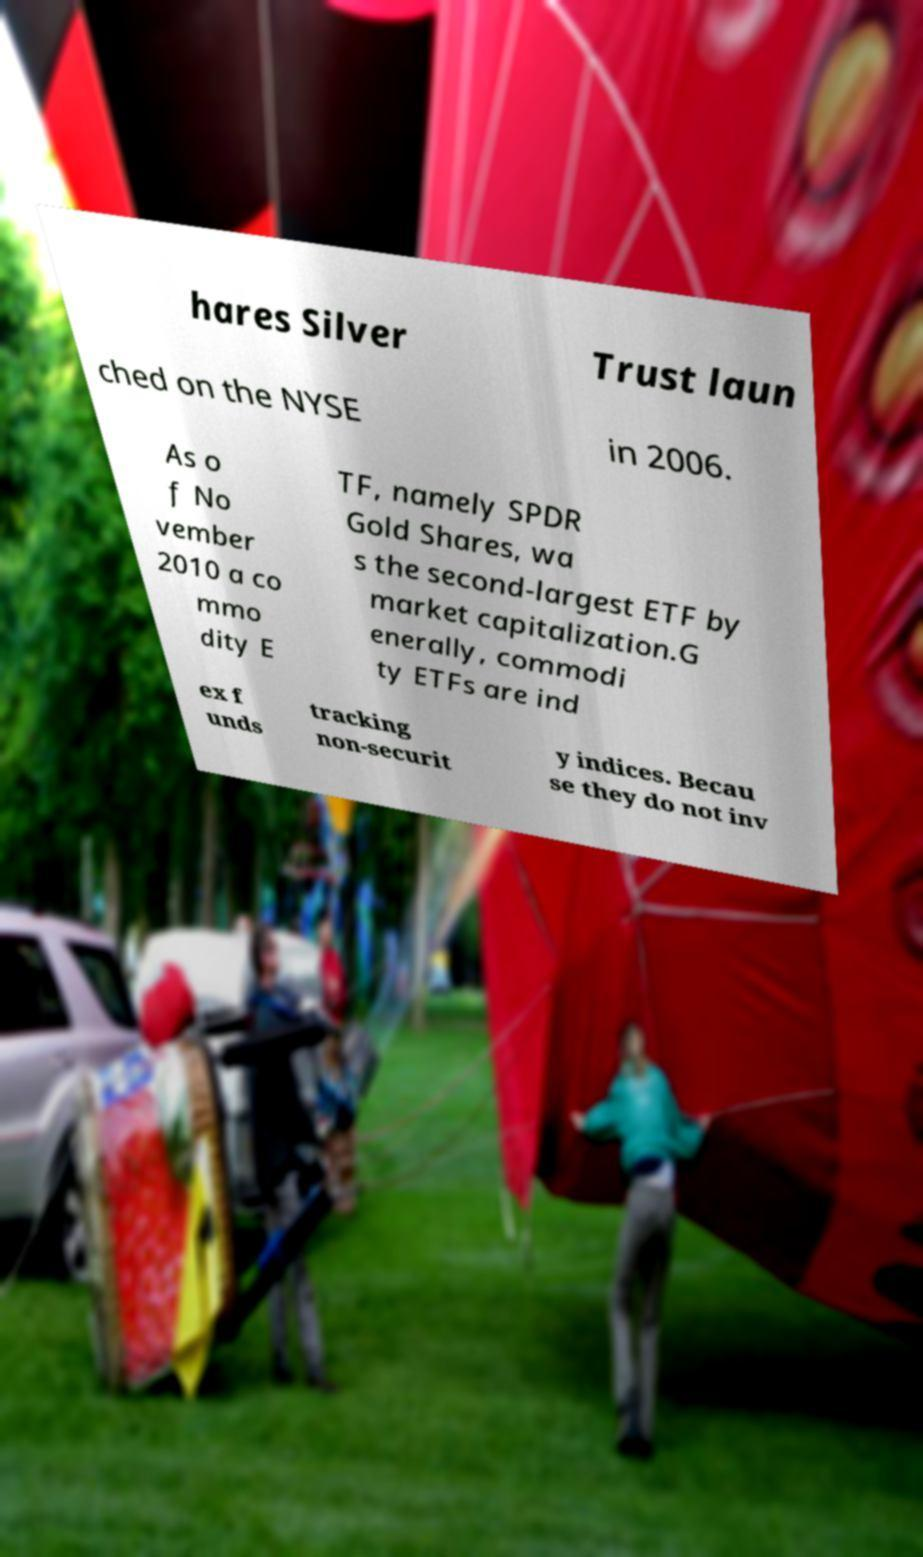Could you extract and type out the text from this image? hares Silver Trust laun ched on the NYSE in 2006. As o f No vember 2010 a co mmo dity E TF, namely SPDR Gold Shares, wa s the second-largest ETF by market capitalization.G enerally, commodi ty ETFs are ind ex f unds tracking non-securit y indices. Becau se they do not inv 